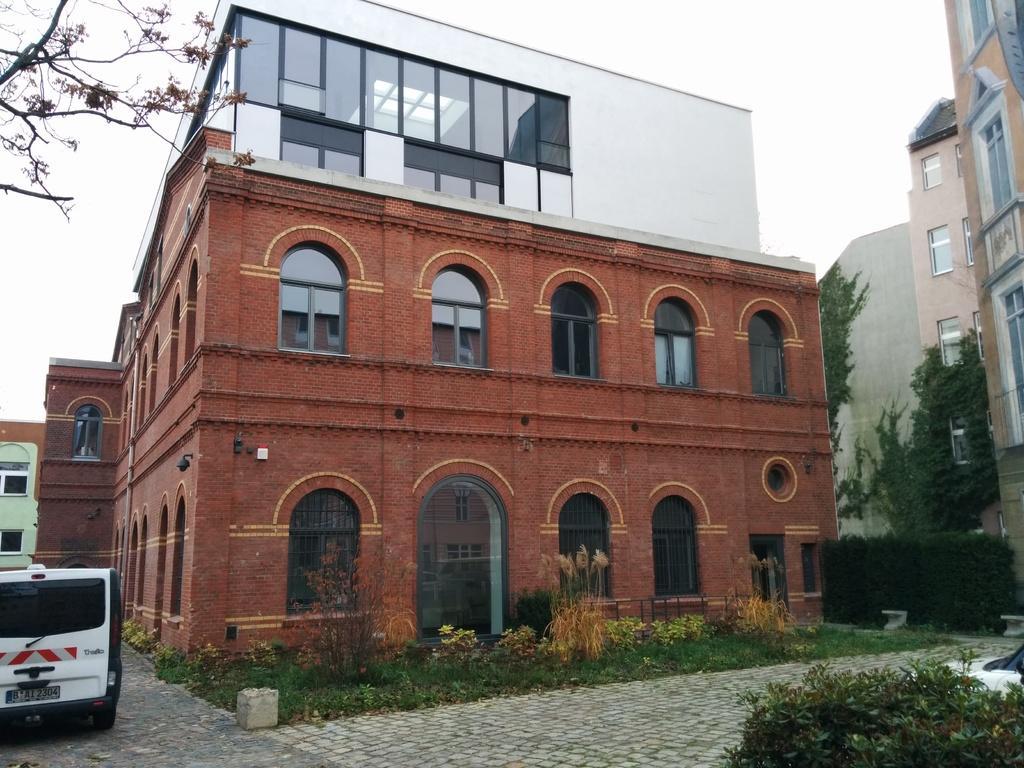Can you describe this image briefly? In this image I can see few buildings in brown, cream and white color, in front I can see a vehicles in white color, few trees in green color and sky is in white color. 